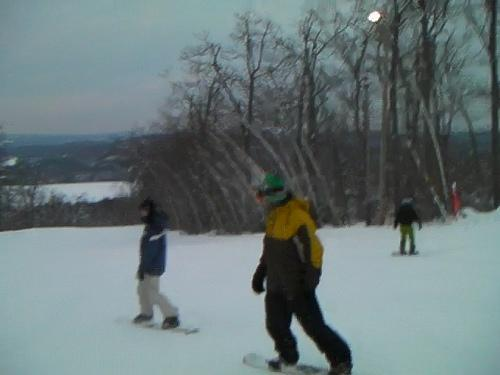Where does the white light come from?

Choices:
A) sun
B) lamp
C) star
D) moon lamp 